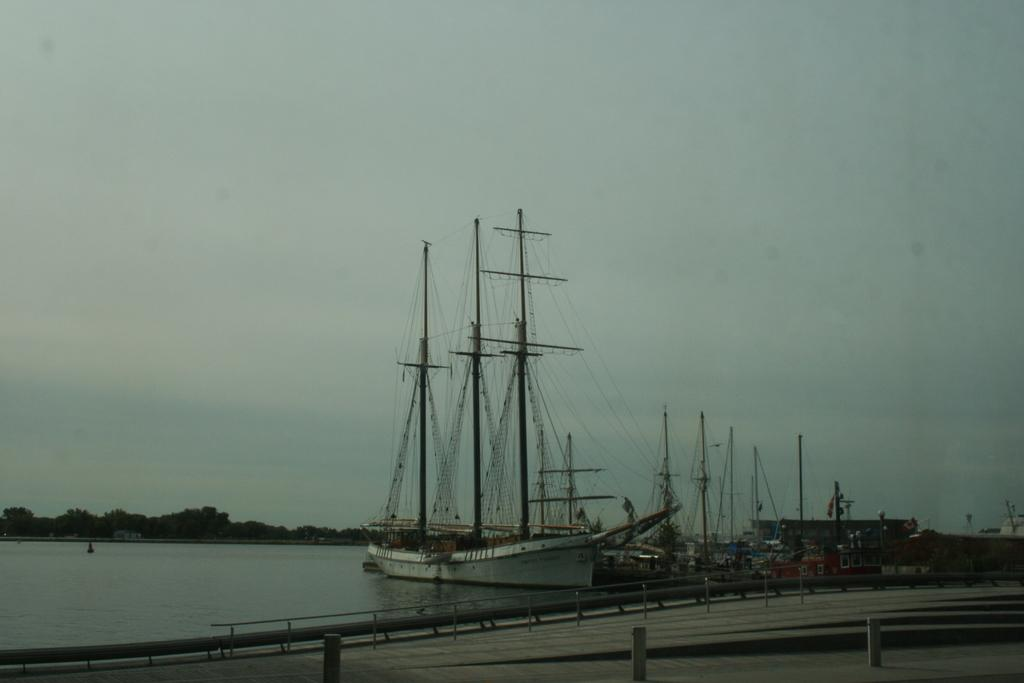What type of structures can be seen in the image? There are paths, fencing, and poles visible in the image. What objects are present in the water? There are boats in the water in the image. What type of wires are present in the image? There are wires visible in the image. What natural elements can be seen in the image? There is water, trees, and the sky visible in the image. What type of reaction can be seen on the lip of the person in the image? There is no person present in the image, so it is not possible to observe a reaction on a lip. 